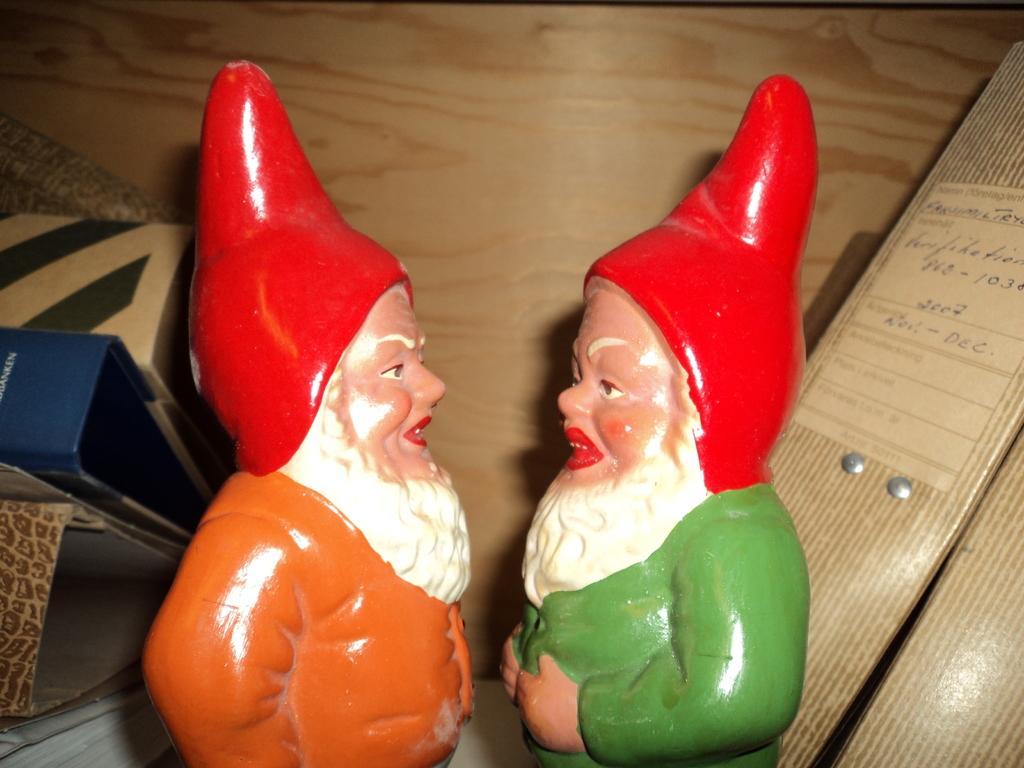What objects are in the center of the image? There are two toys in the center of the image. What can be seen in the background of the image? There are files in the background of the image. What type of throne is visible in the image? There is no throne present in the image. What is the size of the quarter in the image? There is no quarter present in the image. 